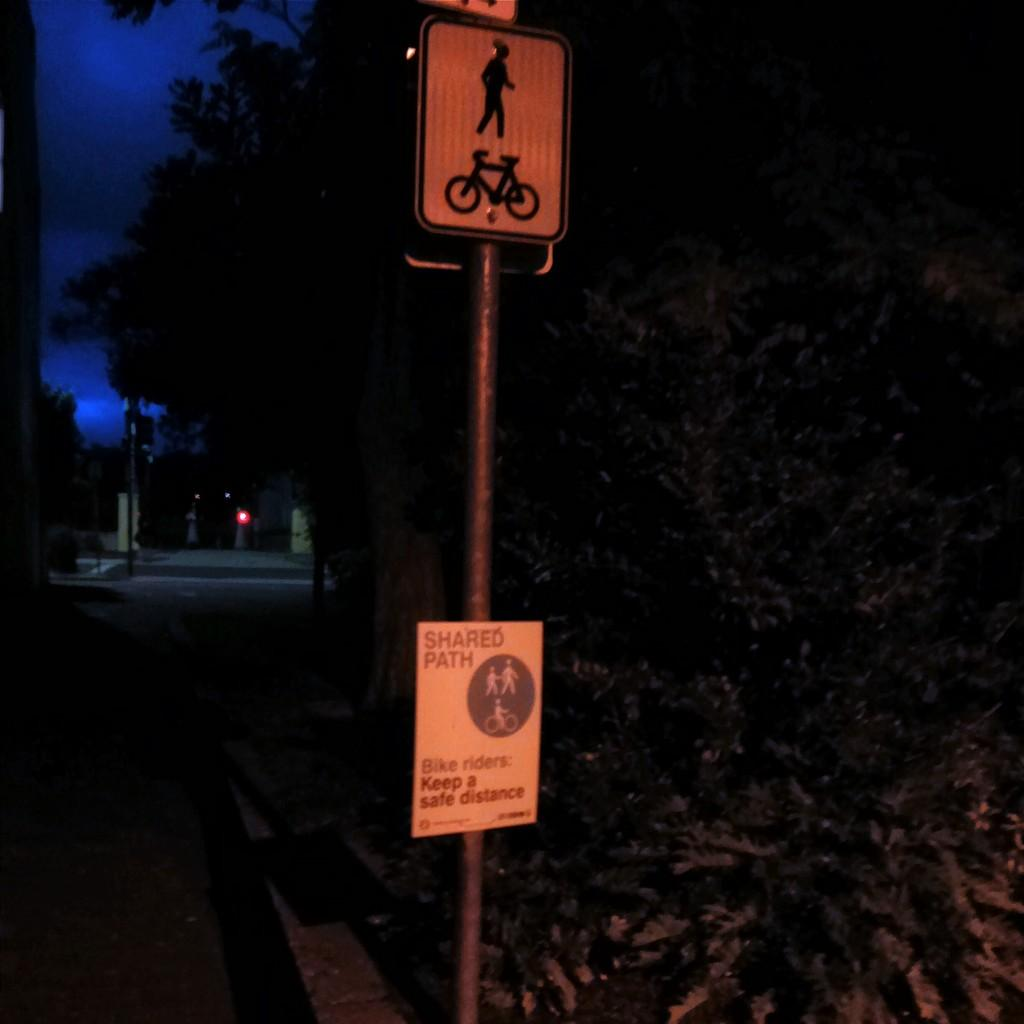How many sign boards can be seen in the image? There are two sign boards in the image. Where are the sign boards located? The sign boards are attached to a pole. What can be seen in the background of the image? There are trees, a road, and sky visible in the background of the image. Can you describe the unspecified objects in the background? Unfortunately, the provided facts do not specify the nature of the unspecified objects in the background. What type of grape can be seen hanging from the trees in the image? There is no grape present in the image, and the trees in the background are not specified as fruit-bearing trees. Can you tell me how many zebras are visible in the image? There are no zebras present in the image; the background features trees and a road. 